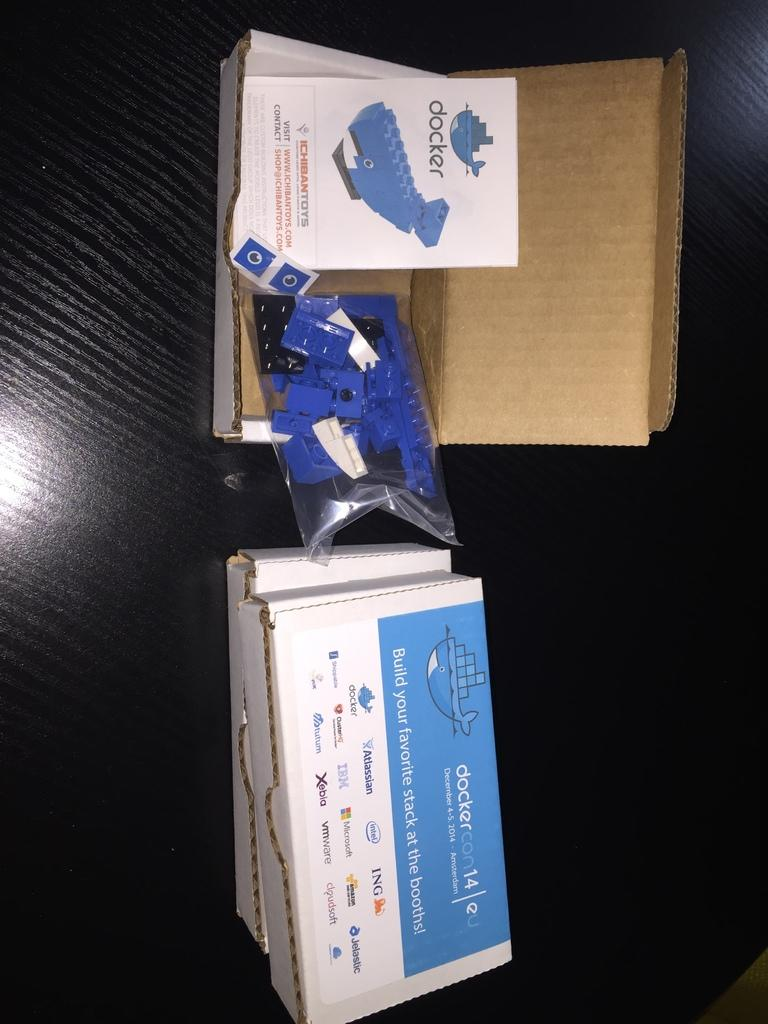<image>
Provide a brief description of the given image. A toy box with Docker toys is opened and shows the instruction manual. 